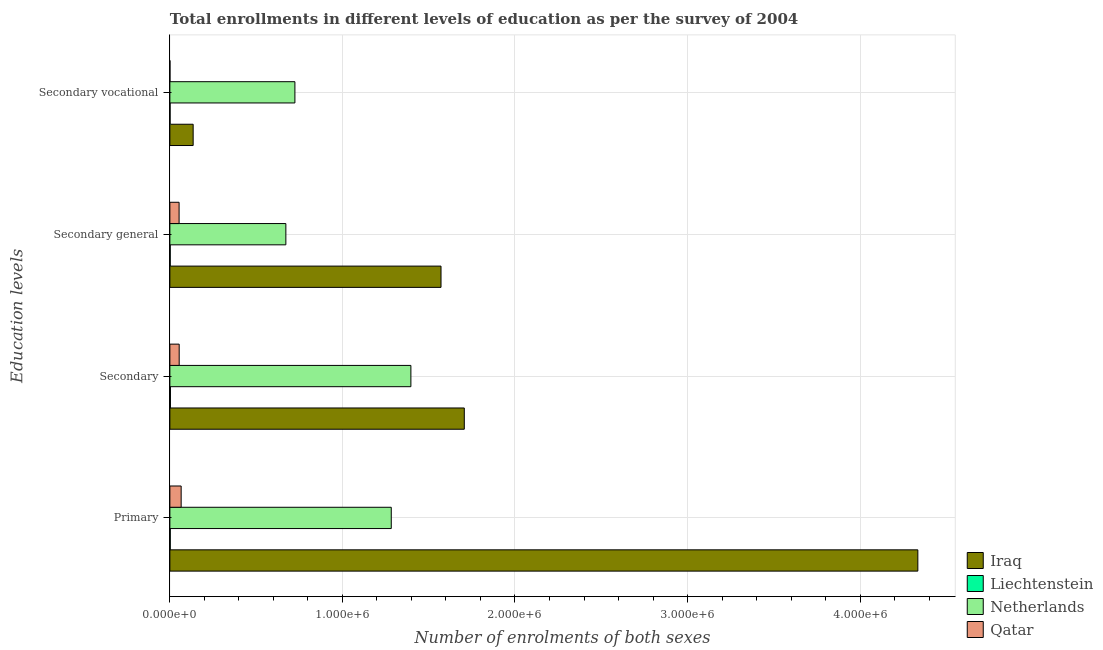How many different coloured bars are there?
Your answer should be compact. 4. Are the number of bars per tick equal to the number of legend labels?
Offer a very short reply. Yes. What is the label of the 3rd group of bars from the top?
Your response must be concise. Secondary. What is the number of enrolments in secondary vocational education in Qatar?
Keep it short and to the point. 493. Across all countries, what is the maximum number of enrolments in secondary general education?
Your answer should be very brief. 1.57e+06. Across all countries, what is the minimum number of enrolments in primary education?
Provide a short and direct response. 2266. In which country was the number of enrolments in secondary education maximum?
Make the answer very short. Iraq. In which country was the number of enrolments in secondary general education minimum?
Give a very brief answer. Liechtenstein. What is the total number of enrolments in secondary vocational education in the graph?
Provide a succinct answer. 8.61e+05. What is the difference between the number of enrolments in primary education in Qatar and that in Liechtenstein?
Give a very brief answer. 6.31e+04. What is the difference between the number of enrolments in secondary general education in Netherlands and the number of enrolments in primary education in Liechtenstein?
Give a very brief answer. 6.70e+05. What is the average number of enrolments in secondary vocational education per country?
Provide a succinct answer. 2.15e+05. What is the difference between the number of enrolments in secondary vocational education and number of enrolments in secondary general education in Qatar?
Give a very brief answer. -5.30e+04. In how many countries, is the number of enrolments in secondary education greater than 2000000 ?
Provide a succinct answer. 0. What is the ratio of the number of enrolments in secondary general education in Iraq to that in Liechtenstein?
Your answer should be compact. 795.59. Is the difference between the number of enrolments in secondary vocational education in Qatar and Iraq greater than the difference between the number of enrolments in secondary general education in Qatar and Iraq?
Ensure brevity in your answer.  Yes. What is the difference between the highest and the second highest number of enrolments in secondary general education?
Provide a short and direct response. 8.99e+05. What is the difference between the highest and the lowest number of enrolments in secondary education?
Give a very brief answer. 1.70e+06. In how many countries, is the number of enrolments in primary education greater than the average number of enrolments in primary education taken over all countries?
Your answer should be compact. 1. Is the sum of the number of enrolments in secondary vocational education in Iraq and Qatar greater than the maximum number of enrolments in secondary education across all countries?
Make the answer very short. No. Is it the case that in every country, the sum of the number of enrolments in secondary education and number of enrolments in secondary vocational education is greater than the sum of number of enrolments in secondary general education and number of enrolments in primary education?
Keep it short and to the point. No. What does the 1st bar from the top in Primary represents?
Your response must be concise. Qatar. What does the 4th bar from the bottom in Primary represents?
Provide a short and direct response. Qatar. What is the difference between two consecutive major ticks on the X-axis?
Offer a terse response. 1.00e+06. Are the values on the major ticks of X-axis written in scientific E-notation?
Your answer should be compact. Yes. Does the graph contain grids?
Make the answer very short. Yes. Where does the legend appear in the graph?
Give a very brief answer. Bottom right. How many legend labels are there?
Your answer should be very brief. 4. What is the title of the graph?
Make the answer very short. Total enrollments in different levels of education as per the survey of 2004. Does "Madagascar" appear as one of the legend labels in the graph?
Your answer should be very brief. No. What is the label or title of the X-axis?
Offer a very short reply. Number of enrolments of both sexes. What is the label or title of the Y-axis?
Offer a very short reply. Education levels. What is the Number of enrolments of both sexes in Iraq in Primary?
Give a very brief answer. 4.33e+06. What is the Number of enrolments of both sexes in Liechtenstein in Primary?
Provide a succinct answer. 2266. What is the Number of enrolments of both sexes of Netherlands in Primary?
Offer a terse response. 1.28e+06. What is the Number of enrolments of both sexes of Qatar in Primary?
Your answer should be compact. 6.54e+04. What is the Number of enrolments of both sexes of Iraq in Secondary?
Offer a terse response. 1.71e+06. What is the Number of enrolments of both sexes in Liechtenstein in Secondary?
Your answer should be compact. 3273. What is the Number of enrolments of both sexes in Netherlands in Secondary?
Your answer should be compact. 1.40e+06. What is the Number of enrolments of both sexes of Qatar in Secondary?
Your response must be concise. 5.40e+04. What is the Number of enrolments of both sexes in Iraq in Secondary general?
Your answer should be compact. 1.57e+06. What is the Number of enrolments of both sexes of Liechtenstein in Secondary general?
Offer a very short reply. 1975. What is the Number of enrolments of both sexes of Netherlands in Secondary general?
Ensure brevity in your answer.  6.72e+05. What is the Number of enrolments of both sexes of Qatar in Secondary general?
Your response must be concise. 5.35e+04. What is the Number of enrolments of both sexes in Iraq in Secondary vocational?
Give a very brief answer. 1.35e+05. What is the Number of enrolments of both sexes of Liechtenstein in Secondary vocational?
Give a very brief answer. 1171. What is the Number of enrolments of both sexes of Netherlands in Secondary vocational?
Keep it short and to the point. 7.25e+05. What is the Number of enrolments of both sexes in Qatar in Secondary vocational?
Make the answer very short. 493. Across all Education levels, what is the maximum Number of enrolments of both sexes in Iraq?
Your response must be concise. 4.33e+06. Across all Education levels, what is the maximum Number of enrolments of both sexes of Liechtenstein?
Your answer should be very brief. 3273. Across all Education levels, what is the maximum Number of enrolments of both sexes of Netherlands?
Your answer should be compact. 1.40e+06. Across all Education levels, what is the maximum Number of enrolments of both sexes in Qatar?
Provide a short and direct response. 6.54e+04. Across all Education levels, what is the minimum Number of enrolments of both sexes of Iraq?
Offer a very short reply. 1.35e+05. Across all Education levels, what is the minimum Number of enrolments of both sexes in Liechtenstein?
Offer a terse response. 1171. Across all Education levels, what is the minimum Number of enrolments of both sexes of Netherlands?
Provide a succinct answer. 6.72e+05. Across all Education levels, what is the minimum Number of enrolments of both sexes of Qatar?
Your response must be concise. 493. What is the total Number of enrolments of both sexes of Iraq in the graph?
Keep it short and to the point. 7.75e+06. What is the total Number of enrolments of both sexes of Liechtenstein in the graph?
Your answer should be very brief. 8685. What is the total Number of enrolments of both sexes in Netherlands in the graph?
Your response must be concise. 4.08e+06. What is the total Number of enrolments of both sexes of Qatar in the graph?
Offer a terse response. 1.73e+05. What is the difference between the Number of enrolments of both sexes in Iraq in Primary and that in Secondary?
Ensure brevity in your answer.  2.63e+06. What is the difference between the Number of enrolments of both sexes in Liechtenstein in Primary and that in Secondary?
Keep it short and to the point. -1007. What is the difference between the Number of enrolments of both sexes of Netherlands in Primary and that in Secondary?
Ensure brevity in your answer.  -1.14e+05. What is the difference between the Number of enrolments of both sexes of Qatar in Primary and that in Secondary?
Provide a short and direct response. 1.14e+04. What is the difference between the Number of enrolments of both sexes of Iraq in Primary and that in Secondary general?
Your answer should be very brief. 2.76e+06. What is the difference between the Number of enrolments of both sexes of Liechtenstein in Primary and that in Secondary general?
Your answer should be very brief. 291. What is the difference between the Number of enrolments of both sexes in Netherlands in Primary and that in Secondary general?
Your answer should be compact. 6.11e+05. What is the difference between the Number of enrolments of both sexes of Qatar in Primary and that in Secondary general?
Your response must be concise. 1.19e+04. What is the difference between the Number of enrolments of both sexes of Iraq in Primary and that in Secondary vocational?
Your response must be concise. 4.20e+06. What is the difference between the Number of enrolments of both sexes in Liechtenstein in Primary and that in Secondary vocational?
Your response must be concise. 1095. What is the difference between the Number of enrolments of both sexes in Netherlands in Primary and that in Secondary vocational?
Ensure brevity in your answer.  5.58e+05. What is the difference between the Number of enrolments of both sexes of Qatar in Primary and that in Secondary vocational?
Give a very brief answer. 6.49e+04. What is the difference between the Number of enrolments of both sexes of Iraq in Secondary and that in Secondary general?
Your answer should be compact. 1.35e+05. What is the difference between the Number of enrolments of both sexes in Liechtenstein in Secondary and that in Secondary general?
Your response must be concise. 1298. What is the difference between the Number of enrolments of both sexes of Netherlands in Secondary and that in Secondary general?
Provide a short and direct response. 7.25e+05. What is the difference between the Number of enrolments of both sexes in Qatar in Secondary and that in Secondary general?
Your answer should be compact. 493. What is the difference between the Number of enrolments of both sexes in Iraq in Secondary and that in Secondary vocational?
Your answer should be compact. 1.57e+06. What is the difference between the Number of enrolments of both sexes of Liechtenstein in Secondary and that in Secondary vocational?
Offer a terse response. 2102. What is the difference between the Number of enrolments of both sexes in Netherlands in Secondary and that in Secondary vocational?
Offer a very short reply. 6.72e+05. What is the difference between the Number of enrolments of both sexes of Qatar in Secondary and that in Secondary vocational?
Offer a terse response. 5.35e+04. What is the difference between the Number of enrolments of both sexes of Iraq in Secondary general and that in Secondary vocational?
Offer a very short reply. 1.44e+06. What is the difference between the Number of enrolments of both sexes in Liechtenstein in Secondary general and that in Secondary vocational?
Keep it short and to the point. 804. What is the difference between the Number of enrolments of both sexes in Netherlands in Secondary general and that in Secondary vocational?
Provide a short and direct response. -5.25e+04. What is the difference between the Number of enrolments of both sexes in Qatar in Secondary general and that in Secondary vocational?
Provide a succinct answer. 5.30e+04. What is the difference between the Number of enrolments of both sexes in Iraq in Primary and the Number of enrolments of both sexes in Liechtenstein in Secondary?
Offer a terse response. 4.33e+06. What is the difference between the Number of enrolments of both sexes of Iraq in Primary and the Number of enrolments of both sexes of Netherlands in Secondary?
Offer a terse response. 2.94e+06. What is the difference between the Number of enrolments of both sexes of Iraq in Primary and the Number of enrolments of both sexes of Qatar in Secondary?
Your response must be concise. 4.28e+06. What is the difference between the Number of enrolments of both sexes of Liechtenstein in Primary and the Number of enrolments of both sexes of Netherlands in Secondary?
Give a very brief answer. -1.39e+06. What is the difference between the Number of enrolments of both sexes in Liechtenstein in Primary and the Number of enrolments of both sexes in Qatar in Secondary?
Your answer should be very brief. -5.17e+04. What is the difference between the Number of enrolments of both sexes of Netherlands in Primary and the Number of enrolments of both sexes of Qatar in Secondary?
Your answer should be very brief. 1.23e+06. What is the difference between the Number of enrolments of both sexes in Iraq in Primary and the Number of enrolments of both sexes in Liechtenstein in Secondary general?
Give a very brief answer. 4.33e+06. What is the difference between the Number of enrolments of both sexes of Iraq in Primary and the Number of enrolments of both sexes of Netherlands in Secondary general?
Offer a very short reply. 3.66e+06. What is the difference between the Number of enrolments of both sexes of Iraq in Primary and the Number of enrolments of both sexes of Qatar in Secondary general?
Give a very brief answer. 4.28e+06. What is the difference between the Number of enrolments of both sexes of Liechtenstein in Primary and the Number of enrolments of both sexes of Netherlands in Secondary general?
Your response must be concise. -6.70e+05. What is the difference between the Number of enrolments of both sexes of Liechtenstein in Primary and the Number of enrolments of both sexes of Qatar in Secondary general?
Provide a succinct answer. -5.12e+04. What is the difference between the Number of enrolments of both sexes of Netherlands in Primary and the Number of enrolments of both sexes of Qatar in Secondary general?
Keep it short and to the point. 1.23e+06. What is the difference between the Number of enrolments of both sexes in Iraq in Primary and the Number of enrolments of both sexes in Liechtenstein in Secondary vocational?
Provide a short and direct response. 4.33e+06. What is the difference between the Number of enrolments of both sexes of Iraq in Primary and the Number of enrolments of both sexes of Netherlands in Secondary vocational?
Keep it short and to the point. 3.61e+06. What is the difference between the Number of enrolments of both sexes in Iraq in Primary and the Number of enrolments of both sexes in Qatar in Secondary vocational?
Your response must be concise. 4.33e+06. What is the difference between the Number of enrolments of both sexes in Liechtenstein in Primary and the Number of enrolments of both sexes in Netherlands in Secondary vocational?
Offer a very short reply. -7.22e+05. What is the difference between the Number of enrolments of both sexes in Liechtenstein in Primary and the Number of enrolments of both sexes in Qatar in Secondary vocational?
Provide a short and direct response. 1773. What is the difference between the Number of enrolments of both sexes of Netherlands in Primary and the Number of enrolments of both sexes of Qatar in Secondary vocational?
Ensure brevity in your answer.  1.28e+06. What is the difference between the Number of enrolments of both sexes of Iraq in Secondary and the Number of enrolments of both sexes of Liechtenstein in Secondary general?
Ensure brevity in your answer.  1.70e+06. What is the difference between the Number of enrolments of both sexes in Iraq in Secondary and the Number of enrolments of both sexes in Netherlands in Secondary general?
Make the answer very short. 1.03e+06. What is the difference between the Number of enrolments of both sexes in Iraq in Secondary and the Number of enrolments of both sexes in Qatar in Secondary general?
Offer a terse response. 1.65e+06. What is the difference between the Number of enrolments of both sexes of Liechtenstein in Secondary and the Number of enrolments of both sexes of Netherlands in Secondary general?
Your answer should be very brief. -6.69e+05. What is the difference between the Number of enrolments of both sexes of Liechtenstein in Secondary and the Number of enrolments of both sexes of Qatar in Secondary general?
Provide a succinct answer. -5.02e+04. What is the difference between the Number of enrolments of both sexes in Netherlands in Secondary and the Number of enrolments of both sexes in Qatar in Secondary general?
Provide a succinct answer. 1.34e+06. What is the difference between the Number of enrolments of both sexes in Iraq in Secondary and the Number of enrolments of both sexes in Liechtenstein in Secondary vocational?
Provide a succinct answer. 1.71e+06. What is the difference between the Number of enrolments of both sexes of Iraq in Secondary and the Number of enrolments of both sexes of Netherlands in Secondary vocational?
Your answer should be compact. 9.82e+05. What is the difference between the Number of enrolments of both sexes in Iraq in Secondary and the Number of enrolments of both sexes in Qatar in Secondary vocational?
Offer a very short reply. 1.71e+06. What is the difference between the Number of enrolments of both sexes in Liechtenstein in Secondary and the Number of enrolments of both sexes in Netherlands in Secondary vocational?
Keep it short and to the point. -7.21e+05. What is the difference between the Number of enrolments of both sexes in Liechtenstein in Secondary and the Number of enrolments of both sexes in Qatar in Secondary vocational?
Offer a terse response. 2780. What is the difference between the Number of enrolments of both sexes of Netherlands in Secondary and the Number of enrolments of both sexes of Qatar in Secondary vocational?
Your response must be concise. 1.40e+06. What is the difference between the Number of enrolments of both sexes in Iraq in Secondary general and the Number of enrolments of both sexes in Liechtenstein in Secondary vocational?
Provide a short and direct response. 1.57e+06. What is the difference between the Number of enrolments of both sexes in Iraq in Secondary general and the Number of enrolments of both sexes in Netherlands in Secondary vocational?
Provide a short and direct response. 8.47e+05. What is the difference between the Number of enrolments of both sexes of Iraq in Secondary general and the Number of enrolments of both sexes of Qatar in Secondary vocational?
Make the answer very short. 1.57e+06. What is the difference between the Number of enrolments of both sexes in Liechtenstein in Secondary general and the Number of enrolments of both sexes in Netherlands in Secondary vocational?
Give a very brief answer. -7.23e+05. What is the difference between the Number of enrolments of both sexes of Liechtenstein in Secondary general and the Number of enrolments of both sexes of Qatar in Secondary vocational?
Provide a short and direct response. 1482. What is the difference between the Number of enrolments of both sexes in Netherlands in Secondary general and the Number of enrolments of both sexes in Qatar in Secondary vocational?
Provide a short and direct response. 6.72e+05. What is the average Number of enrolments of both sexes of Iraq per Education levels?
Offer a very short reply. 1.94e+06. What is the average Number of enrolments of both sexes of Liechtenstein per Education levels?
Offer a very short reply. 2171.25. What is the average Number of enrolments of both sexes of Netherlands per Education levels?
Your answer should be very brief. 1.02e+06. What is the average Number of enrolments of both sexes of Qatar per Education levels?
Keep it short and to the point. 4.33e+04. What is the difference between the Number of enrolments of both sexes of Iraq and Number of enrolments of both sexes of Liechtenstein in Primary?
Your answer should be compact. 4.33e+06. What is the difference between the Number of enrolments of both sexes in Iraq and Number of enrolments of both sexes in Netherlands in Primary?
Provide a short and direct response. 3.05e+06. What is the difference between the Number of enrolments of both sexes in Iraq and Number of enrolments of both sexes in Qatar in Primary?
Offer a terse response. 4.27e+06. What is the difference between the Number of enrolments of both sexes in Liechtenstein and Number of enrolments of both sexes in Netherlands in Primary?
Keep it short and to the point. -1.28e+06. What is the difference between the Number of enrolments of both sexes in Liechtenstein and Number of enrolments of both sexes in Qatar in Primary?
Ensure brevity in your answer.  -6.31e+04. What is the difference between the Number of enrolments of both sexes in Netherlands and Number of enrolments of both sexes in Qatar in Primary?
Your response must be concise. 1.22e+06. What is the difference between the Number of enrolments of both sexes in Iraq and Number of enrolments of both sexes in Liechtenstein in Secondary?
Give a very brief answer. 1.70e+06. What is the difference between the Number of enrolments of both sexes of Iraq and Number of enrolments of both sexes of Netherlands in Secondary?
Your answer should be very brief. 3.10e+05. What is the difference between the Number of enrolments of both sexes in Iraq and Number of enrolments of both sexes in Qatar in Secondary?
Make the answer very short. 1.65e+06. What is the difference between the Number of enrolments of both sexes of Liechtenstein and Number of enrolments of both sexes of Netherlands in Secondary?
Offer a terse response. -1.39e+06. What is the difference between the Number of enrolments of both sexes of Liechtenstein and Number of enrolments of both sexes of Qatar in Secondary?
Make the answer very short. -5.07e+04. What is the difference between the Number of enrolments of both sexes of Netherlands and Number of enrolments of both sexes of Qatar in Secondary?
Ensure brevity in your answer.  1.34e+06. What is the difference between the Number of enrolments of both sexes of Iraq and Number of enrolments of both sexes of Liechtenstein in Secondary general?
Make the answer very short. 1.57e+06. What is the difference between the Number of enrolments of both sexes of Iraq and Number of enrolments of both sexes of Netherlands in Secondary general?
Give a very brief answer. 8.99e+05. What is the difference between the Number of enrolments of both sexes of Iraq and Number of enrolments of both sexes of Qatar in Secondary general?
Provide a short and direct response. 1.52e+06. What is the difference between the Number of enrolments of both sexes in Liechtenstein and Number of enrolments of both sexes in Netherlands in Secondary general?
Your answer should be compact. -6.70e+05. What is the difference between the Number of enrolments of both sexes of Liechtenstein and Number of enrolments of both sexes of Qatar in Secondary general?
Your answer should be very brief. -5.15e+04. What is the difference between the Number of enrolments of both sexes in Netherlands and Number of enrolments of both sexes in Qatar in Secondary general?
Keep it short and to the point. 6.19e+05. What is the difference between the Number of enrolments of both sexes of Iraq and Number of enrolments of both sexes of Liechtenstein in Secondary vocational?
Your answer should be very brief. 1.34e+05. What is the difference between the Number of enrolments of both sexes in Iraq and Number of enrolments of both sexes in Netherlands in Secondary vocational?
Offer a terse response. -5.90e+05. What is the difference between the Number of enrolments of both sexes of Iraq and Number of enrolments of both sexes of Qatar in Secondary vocational?
Your answer should be compact. 1.34e+05. What is the difference between the Number of enrolments of both sexes of Liechtenstein and Number of enrolments of both sexes of Netherlands in Secondary vocational?
Offer a terse response. -7.23e+05. What is the difference between the Number of enrolments of both sexes of Liechtenstein and Number of enrolments of both sexes of Qatar in Secondary vocational?
Offer a very short reply. 678. What is the difference between the Number of enrolments of both sexes in Netherlands and Number of enrolments of both sexes in Qatar in Secondary vocational?
Provide a short and direct response. 7.24e+05. What is the ratio of the Number of enrolments of both sexes of Iraq in Primary to that in Secondary?
Offer a terse response. 2.54. What is the ratio of the Number of enrolments of both sexes in Liechtenstein in Primary to that in Secondary?
Your answer should be very brief. 0.69. What is the ratio of the Number of enrolments of both sexes of Netherlands in Primary to that in Secondary?
Your answer should be very brief. 0.92. What is the ratio of the Number of enrolments of both sexes of Qatar in Primary to that in Secondary?
Provide a succinct answer. 1.21. What is the ratio of the Number of enrolments of both sexes of Iraq in Primary to that in Secondary general?
Provide a short and direct response. 2.76. What is the ratio of the Number of enrolments of both sexes of Liechtenstein in Primary to that in Secondary general?
Your answer should be compact. 1.15. What is the ratio of the Number of enrolments of both sexes in Netherlands in Primary to that in Secondary general?
Provide a short and direct response. 1.91. What is the ratio of the Number of enrolments of both sexes of Qatar in Primary to that in Secondary general?
Provide a succinct answer. 1.22. What is the ratio of the Number of enrolments of both sexes in Iraq in Primary to that in Secondary vocational?
Provide a succinct answer. 32.12. What is the ratio of the Number of enrolments of both sexes in Liechtenstein in Primary to that in Secondary vocational?
Your response must be concise. 1.94. What is the ratio of the Number of enrolments of both sexes of Netherlands in Primary to that in Secondary vocational?
Provide a short and direct response. 1.77. What is the ratio of the Number of enrolments of both sexes in Qatar in Primary to that in Secondary vocational?
Provide a succinct answer. 132.56. What is the ratio of the Number of enrolments of both sexes in Iraq in Secondary to that in Secondary general?
Provide a succinct answer. 1.09. What is the ratio of the Number of enrolments of both sexes of Liechtenstein in Secondary to that in Secondary general?
Your answer should be very brief. 1.66. What is the ratio of the Number of enrolments of both sexes in Netherlands in Secondary to that in Secondary general?
Offer a terse response. 2.08. What is the ratio of the Number of enrolments of both sexes in Qatar in Secondary to that in Secondary general?
Offer a very short reply. 1.01. What is the ratio of the Number of enrolments of both sexes of Iraq in Secondary to that in Secondary vocational?
Make the answer very short. 12.64. What is the ratio of the Number of enrolments of both sexes in Liechtenstein in Secondary to that in Secondary vocational?
Your answer should be compact. 2.79. What is the ratio of the Number of enrolments of both sexes in Netherlands in Secondary to that in Secondary vocational?
Provide a succinct answer. 1.93. What is the ratio of the Number of enrolments of both sexes of Qatar in Secondary to that in Secondary vocational?
Make the answer very short. 109.44. What is the ratio of the Number of enrolments of both sexes of Iraq in Secondary general to that in Secondary vocational?
Provide a short and direct response. 11.64. What is the ratio of the Number of enrolments of both sexes in Liechtenstein in Secondary general to that in Secondary vocational?
Your response must be concise. 1.69. What is the ratio of the Number of enrolments of both sexes in Netherlands in Secondary general to that in Secondary vocational?
Offer a very short reply. 0.93. What is the ratio of the Number of enrolments of both sexes of Qatar in Secondary general to that in Secondary vocational?
Keep it short and to the point. 108.44. What is the difference between the highest and the second highest Number of enrolments of both sexes of Iraq?
Give a very brief answer. 2.63e+06. What is the difference between the highest and the second highest Number of enrolments of both sexes in Liechtenstein?
Give a very brief answer. 1007. What is the difference between the highest and the second highest Number of enrolments of both sexes of Netherlands?
Ensure brevity in your answer.  1.14e+05. What is the difference between the highest and the second highest Number of enrolments of both sexes of Qatar?
Provide a succinct answer. 1.14e+04. What is the difference between the highest and the lowest Number of enrolments of both sexes in Iraq?
Give a very brief answer. 4.20e+06. What is the difference between the highest and the lowest Number of enrolments of both sexes of Liechtenstein?
Provide a succinct answer. 2102. What is the difference between the highest and the lowest Number of enrolments of both sexes in Netherlands?
Your response must be concise. 7.25e+05. What is the difference between the highest and the lowest Number of enrolments of both sexes of Qatar?
Give a very brief answer. 6.49e+04. 